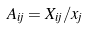<formula> <loc_0><loc_0><loc_500><loc_500>A _ { i j } = X _ { i j } / x _ { j }</formula> 